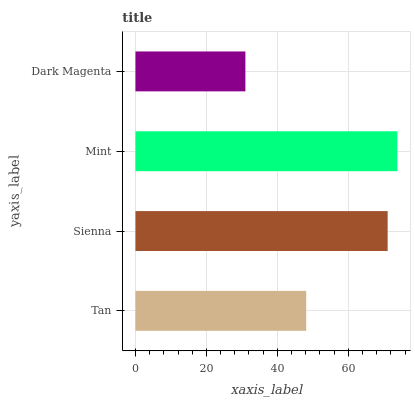Is Dark Magenta the minimum?
Answer yes or no. Yes. Is Mint the maximum?
Answer yes or no. Yes. Is Sienna the minimum?
Answer yes or no. No. Is Sienna the maximum?
Answer yes or no. No. Is Sienna greater than Tan?
Answer yes or no. Yes. Is Tan less than Sienna?
Answer yes or no. Yes. Is Tan greater than Sienna?
Answer yes or no. No. Is Sienna less than Tan?
Answer yes or no. No. Is Sienna the high median?
Answer yes or no. Yes. Is Tan the low median?
Answer yes or no. Yes. Is Dark Magenta the high median?
Answer yes or no. No. Is Mint the low median?
Answer yes or no. No. 